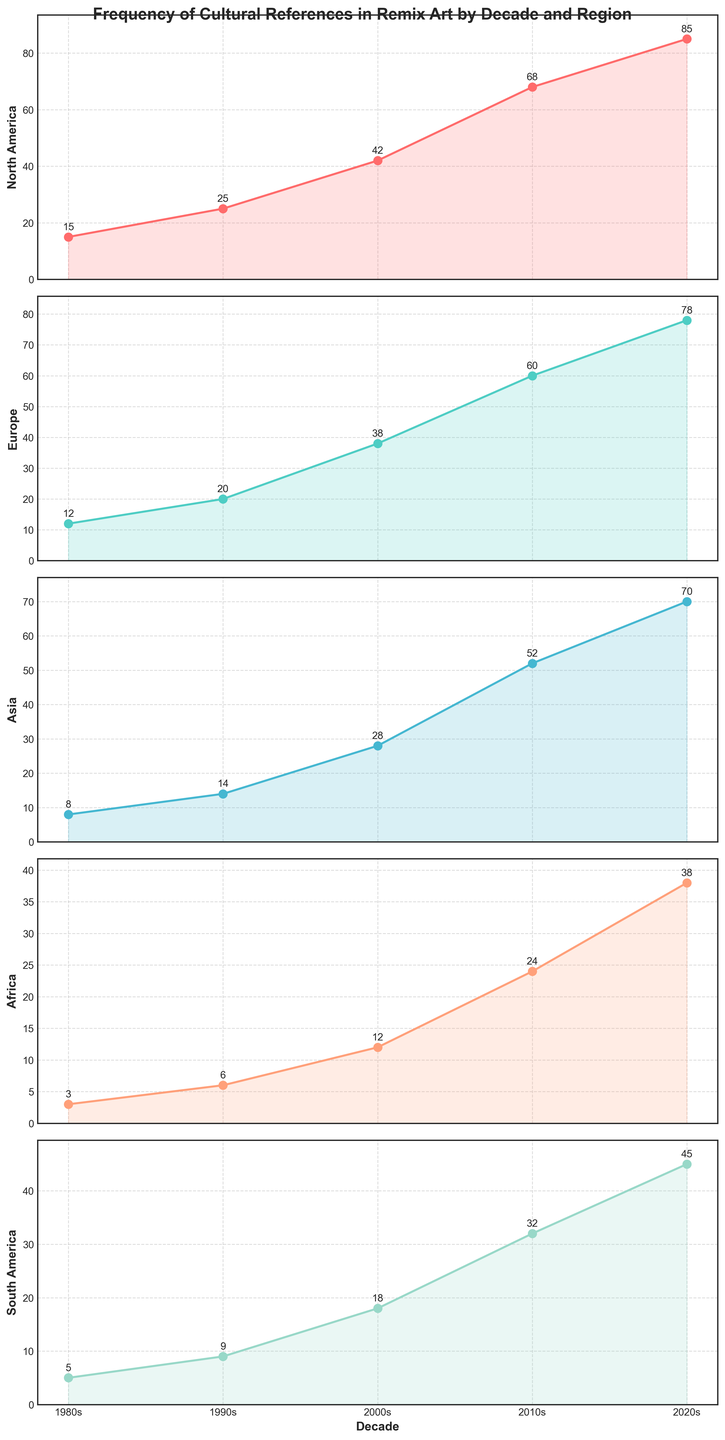What region experienced the most significant increase in cultural references from the 1980s to the 2020s? The largest increase in cultural references can be determined by calculating the difference between the 2020s and the 1980s for each region. For North America, the increase is \(85 - 15 = 70\). For Europe, it is \(78 - 12 = 66\). For Asia, it is \(70 - 8 = 62\). For Africa, it is \(38 - 3 = 35\). For South America, it is \(45 - 5 = 40\). The largest increase is in North America.
Answer: North America Which decade saw the highest increase in cultural references for Asia? To identify the decade with the highest increase for Asia, we need to calculate the difference for each consecutive decade. For the 1980s to 1990s: \(14 - 8 = 6\). For the 1990s to 2000s: \(28 - 14 = 14\). For the 2000s to 2010s: \(52 - 28 = 24\). For the 2010s to 2020s: \(70 - 52 = 18\). The highest increase occurred in the 2000s to 2010s decade.
Answer: 2000s to 2010s How does the trend in cultural references in Africa compare to South America over the decades? Observing the trends for Africa and South America, we see that both regions consistently show an increase over the decades. However, the number of references in South America is higher in every decade when compared to Africa. The increases are also relatively similar in pattern but with a higher starting and ending point for South America.
Answer: South America consistently has more references In which decade did Europe see its highest number of new cultural references? To find the decade with the highest increase, we calculate the difference for each consecutive decade. For the 1980s to 1990s: \(20 - 12 = 8\). For the 1990s to 2000s: \(38 - 20 = 18\). For the 2000s to 2010s: \(60 - 38 = 22\). For the 2010s to 2020s: \(78 - 60 = 18\). The highest increase occurred between the 2000s and 2010s.
Answer: 2000s to 2010s What is the rate of increase in cultural references for North America between each decade? To determine the rate of increase, calculate the difference for each consecutive decade. For the 1980s to 1990s: \(25 - 15 = 10\). For the 1990s to 2000s: \(42 - 25 = 17\). For the 2000s to 2010s: \(68 - 42 = 26\). For the 2010s to 2020s: \(85 - 68 = 17\). North America saw an increase of 10, 17, 26, and 17 references in each respective decade.
Answer: 10, 17, 26, 17 